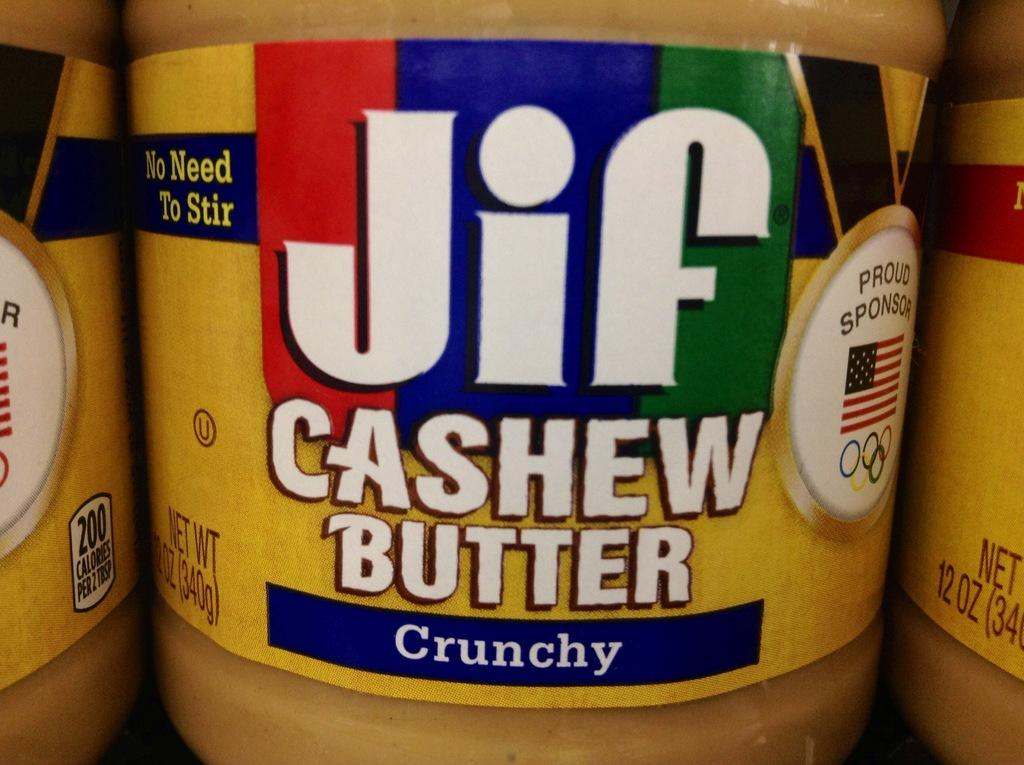Provide a one-sentence caption for the provided image. A close up of a colourful Jif cashew butter jar label. 